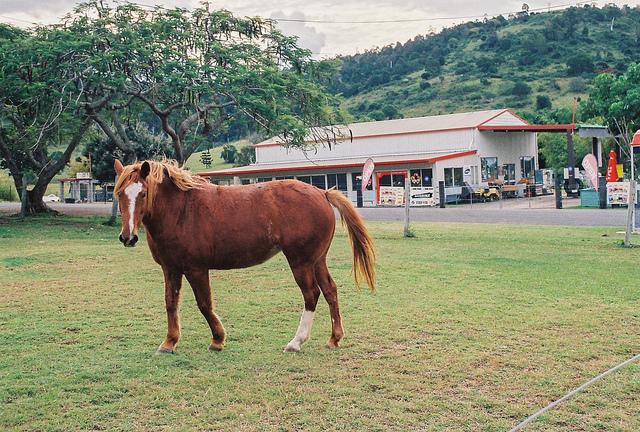Should the horse be running loose?
Concise answer only. No. How many white feet?
Short answer required. 1. Does the horse need gas for fuel?
Keep it brief. No. What animals are on the farm?
Keep it brief. Horse. 